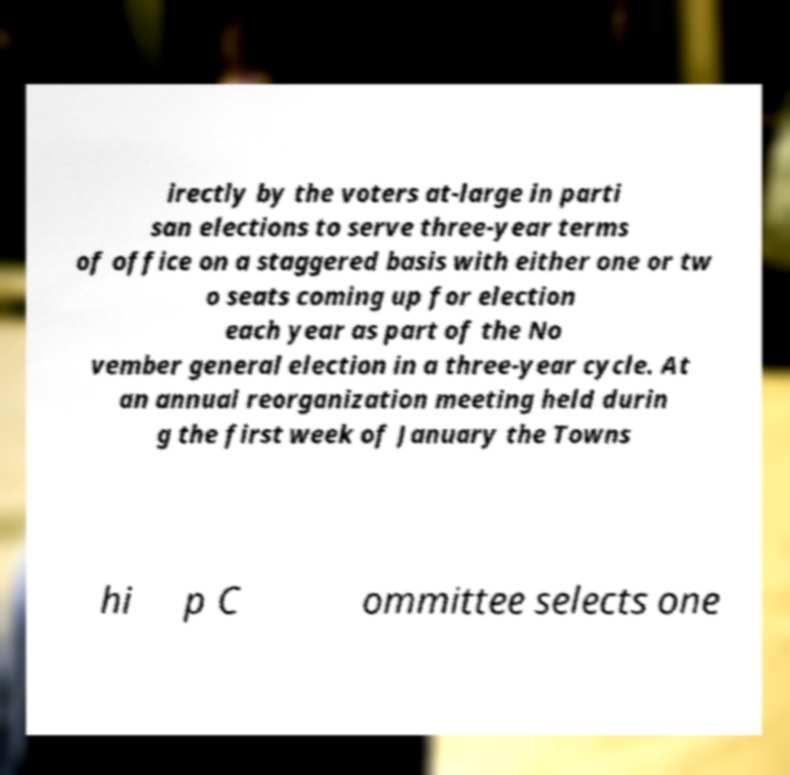Could you assist in decoding the text presented in this image and type it out clearly? irectly by the voters at-large in parti san elections to serve three-year terms of office on a staggered basis with either one or tw o seats coming up for election each year as part of the No vember general election in a three-year cycle. At an annual reorganization meeting held durin g the first week of January the Towns hi p C ommittee selects one 